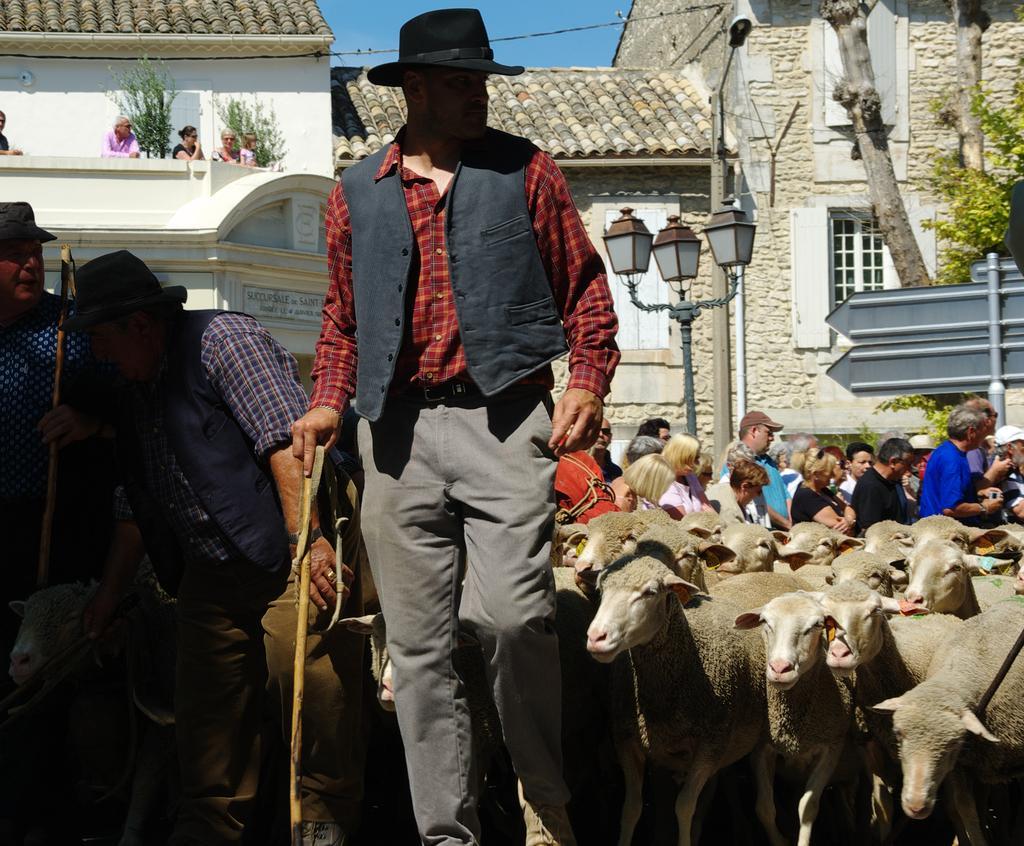Please provide a concise description of this image. In this image there are three persons standing and holding sticks, there are sheep's , group of people standing, lights ,boards, poles, buildings, plants, tree, sky. 